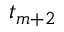Convert formula to latex. <formula><loc_0><loc_0><loc_500><loc_500>t _ { m + 2 }</formula> 